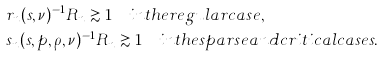<formula> <loc_0><loc_0><loc_500><loc_500>& r _ { n } ( s , \nu ) ^ { - 1 } R _ { n } \gtrsim 1 \quad i n t h e r e g u l a r c a s e , \\ & s _ { n } ( s , p , \rho , \nu ) ^ { - 1 } R _ { n } \gtrsim 1 \quad i n t h e s p a r s e a n d c r i t i c a l c a s e s .</formula> 